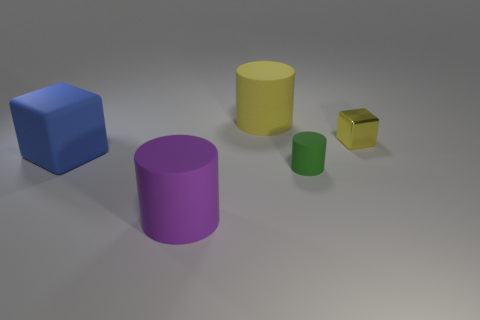Is there any other thing that has the same material as the small cube?
Ensure brevity in your answer.  No. How many other things are there of the same color as the shiny block?
Offer a terse response. 1. The tiny rubber cylinder is what color?
Your answer should be compact. Green. How big is the rubber thing that is on the left side of the yellow rubber cylinder and behind the large purple matte cylinder?
Offer a terse response. Large. How many things are small matte objects behind the large purple rubber cylinder or large matte cylinders?
Provide a succinct answer. 3. What shape is the purple object that is the same material as the large yellow cylinder?
Make the answer very short. Cylinder. What shape is the tiny yellow object?
Provide a succinct answer. Cube. What color is the thing that is both on the left side of the small yellow shiny thing and to the right of the yellow matte cylinder?
Give a very brief answer. Green. What shape is the blue matte thing that is the same size as the yellow rubber thing?
Provide a succinct answer. Cube. Is there another large matte object of the same shape as the purple rubber object?
Provide a short and direct response. Yes. 